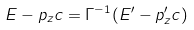<formula> <loc_0><loc_0><loc_500><loc_500>E - p _ { z } c = \Gamma ^ { - 1 } ( E ^ { \prime } - p ^ { \prime } _ { z } c )</formula> 